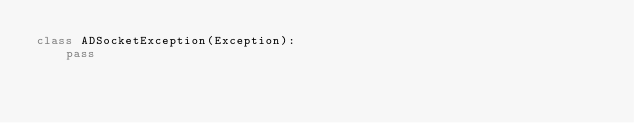<code> <loc_0><loc_0><loc_500><loc_500><_Python_>class ADSocketException(Exception):
    pass
</code> 